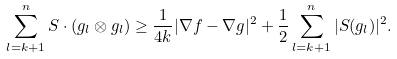Convert formula to latex. <formula><loc_0><loc_0><loc_500><loc_500>\sum _ { l = k + 1 } ^ { n } S \cdot ( { g } _ { l } \otimes { g } _ { l } ) \geq \frac { 1 } { 4 k } | \nabla f - \nabla g | ^ { 2 } + \frac { 1 } { 2 } \sum _ { l = k + 1 } ^ { n } | S ( { g } _ { l } ) | ^ { 2 } .</formula> 